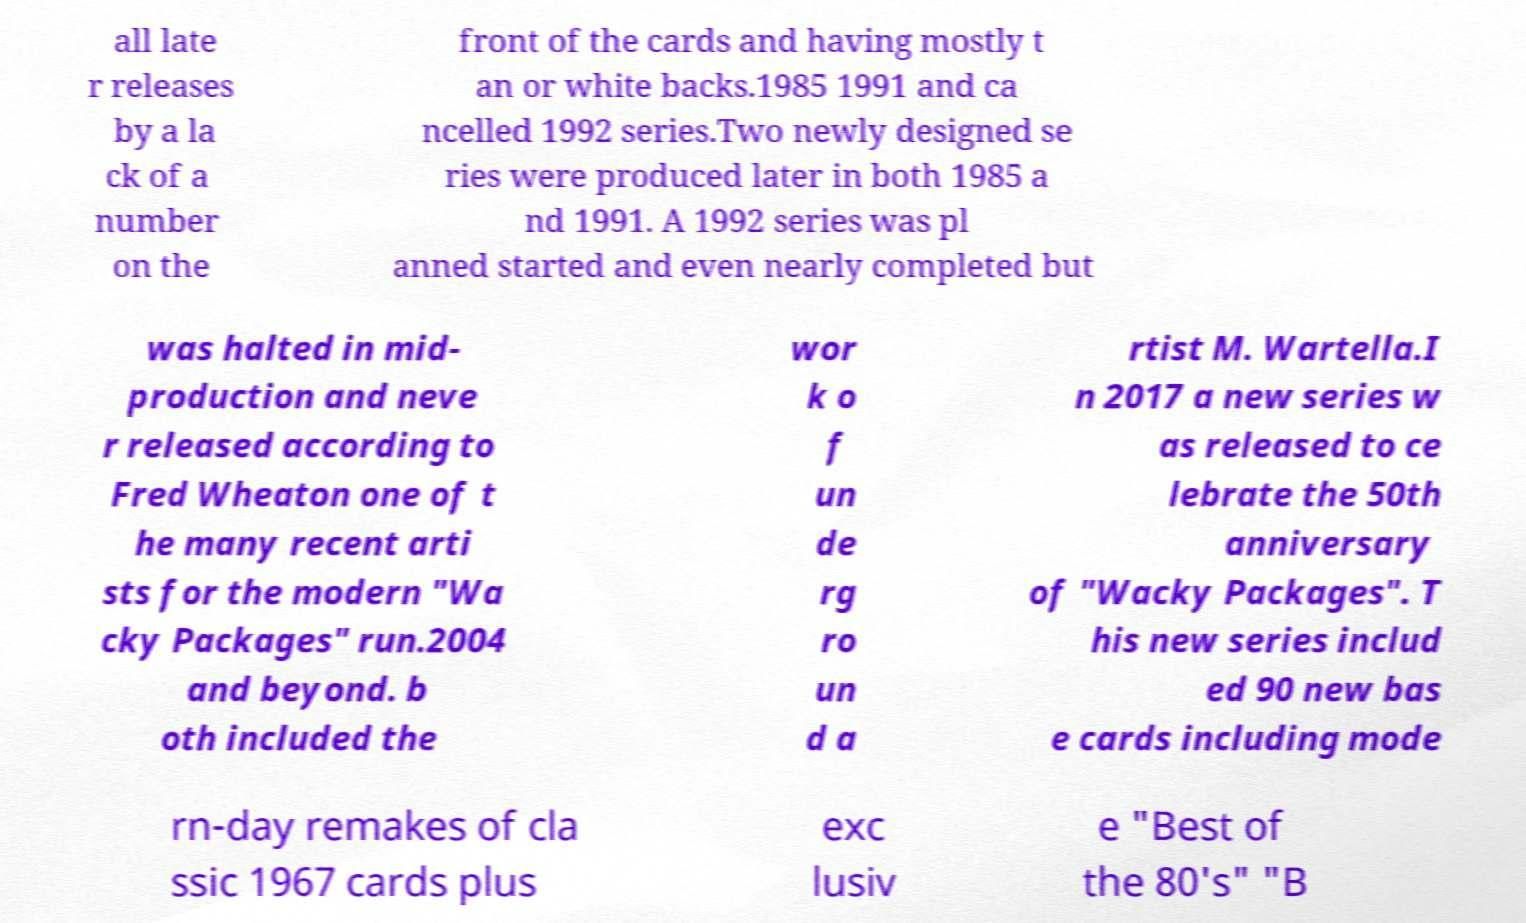I need the written content from this picture converted into text. Can you do that? all late r releases by a la ck of a number on the front of the cards and having mostly t an or white backs.1985 1991 and ca ncelled 1992 series.Two newly designed se ries were produced later in both 1985 a nd 1991. A 1992 series was pl anned started and even nearly completed but was halted in mid- production and neve r released according to Fred Wheaton one of t he many recent arti sts for the modern "Wa cky Packages" run.2004 and beyond. b oth included the wor k o f un de rg ro un d a rtist M. Wartella.I n 2017 a new series w as released to ce lebrate the 50th anniversary of "Wacky Packages". T his new series includ ed 90 new bas e cards including mode rn-day remakes of cla ssic 1967 cards plus exc lusiv e "Best of the 80's" "B 